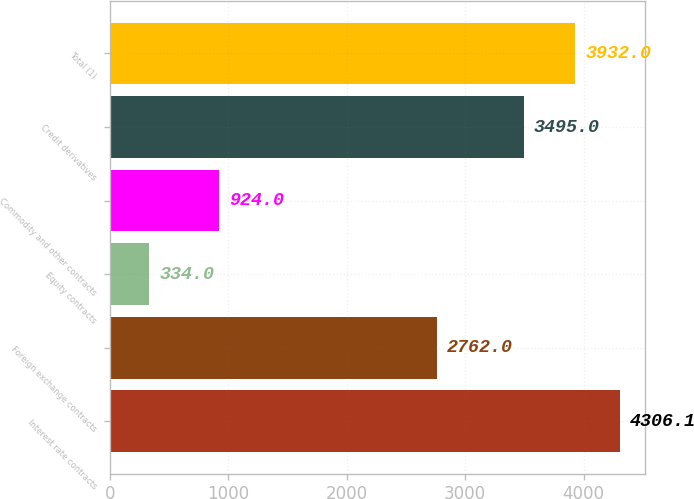Convert chart. <chart><loc_0><loc_0><loc_500><loc_500><bar_chart><fcel>Interest rate contracts<fcel>Foreign exchange contracts<fcel>Equity contracts<fcel>Commodity and other contracts<fcel>Credit derivatives<fcel>Total (1)<nl><fcel>4306.1<fcel>2762<fcel>334<fcel>924<fcel>3495<fcel>3932<nl></chart> 